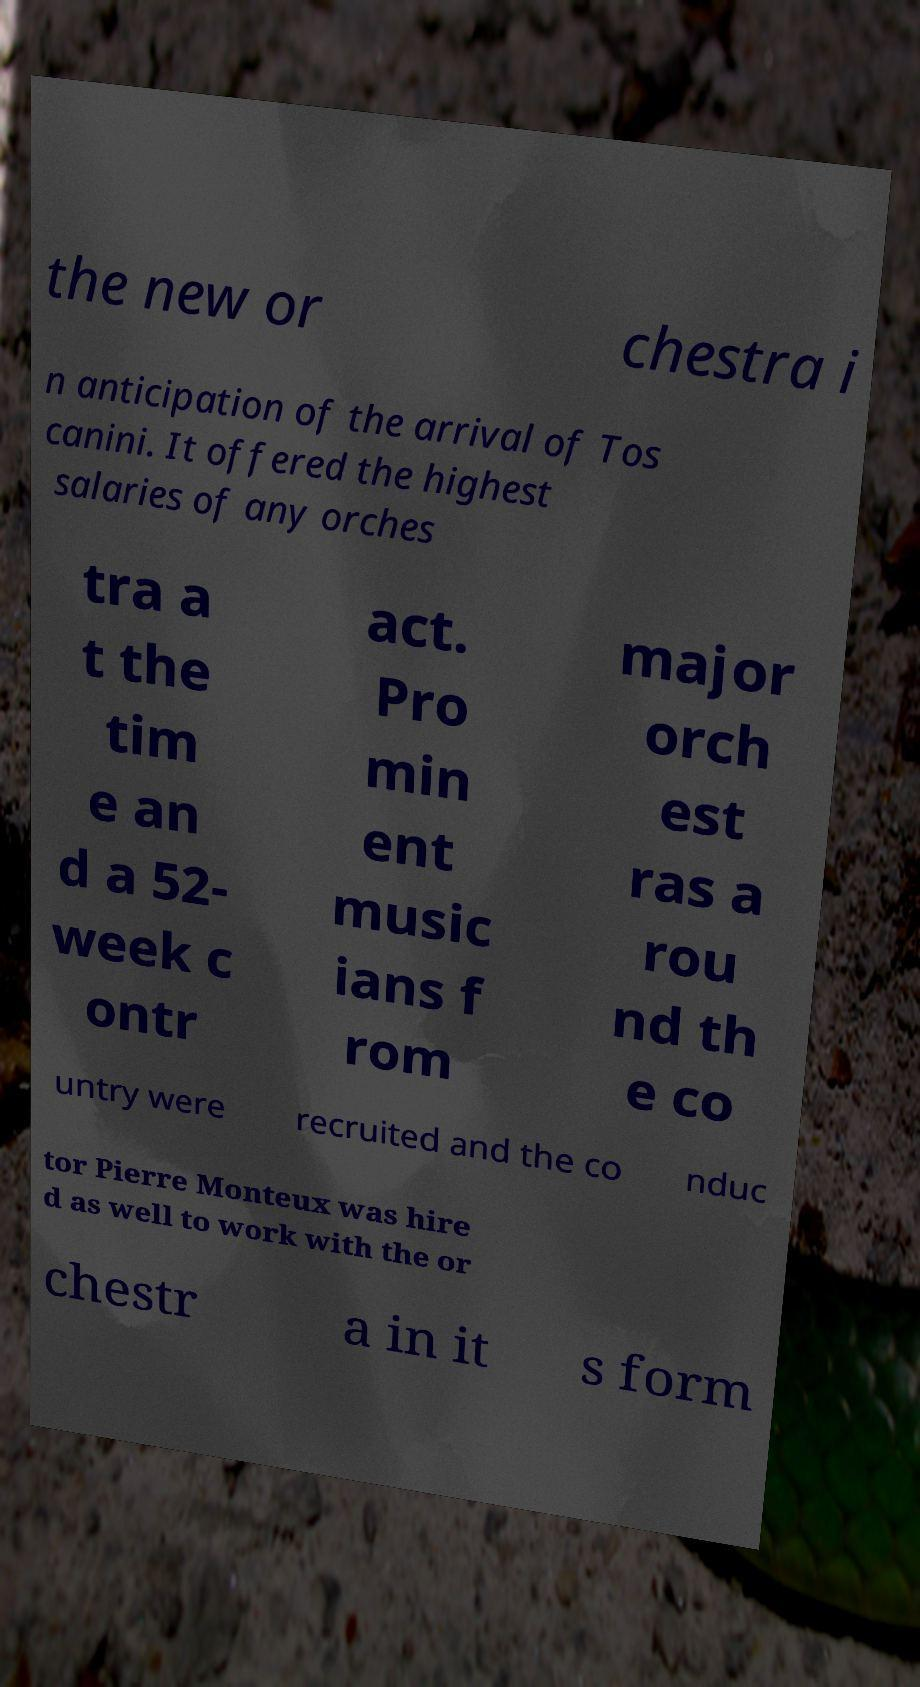I need the written content from this picture converted into text. Can you do that? the new or chestra i n anticipation of the arrival of Tos canini. It offered the highest salaries of any orches tra a t the tim e an d a 52- week c ontr act. Pro min ent music ians f rom major orch est ras a rou nd th e co untry were recruited and the co nduc tor Pierre Monteux was hire d as well to work with the or chestr a in it s form 